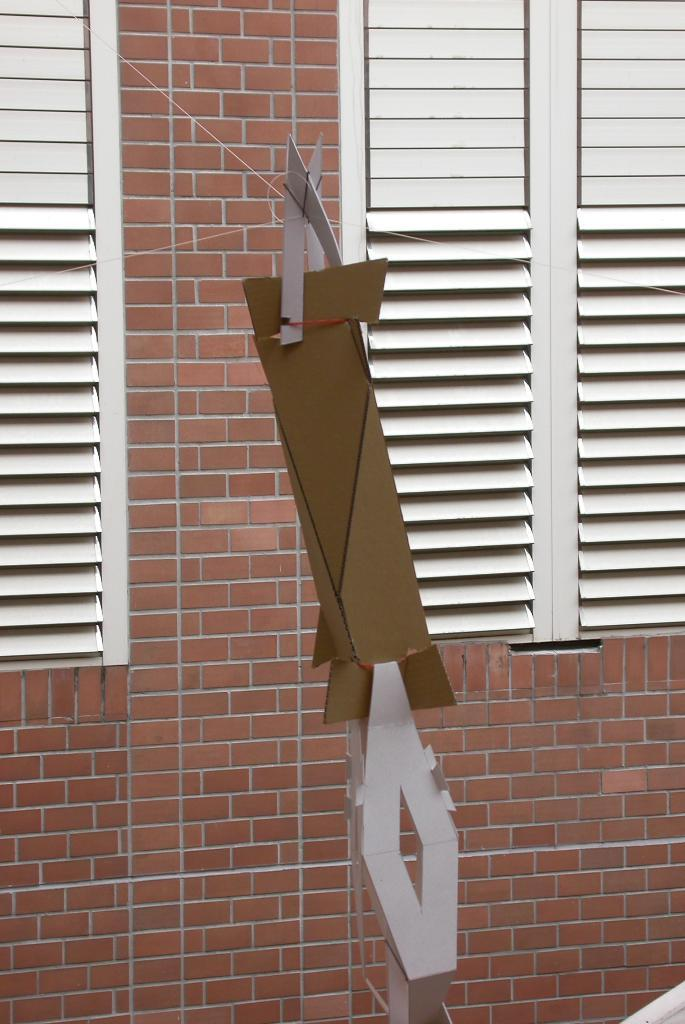Where was the image taken? The image was taken outdoors. What can be seen in the background of the image? There is a wall in the background of the image. What feature is present on the wall? The wall has window blinds. How many windows are on the wall? There are windows on the wall. What is the main object in the middle of the image? There is a cardboard piece in the middle of the image. How much wish is present in the image? There is no mention of a wish or any related object in the image. The image features a wall with window blinds and windows, as well as a cardboard piece in the middle. 